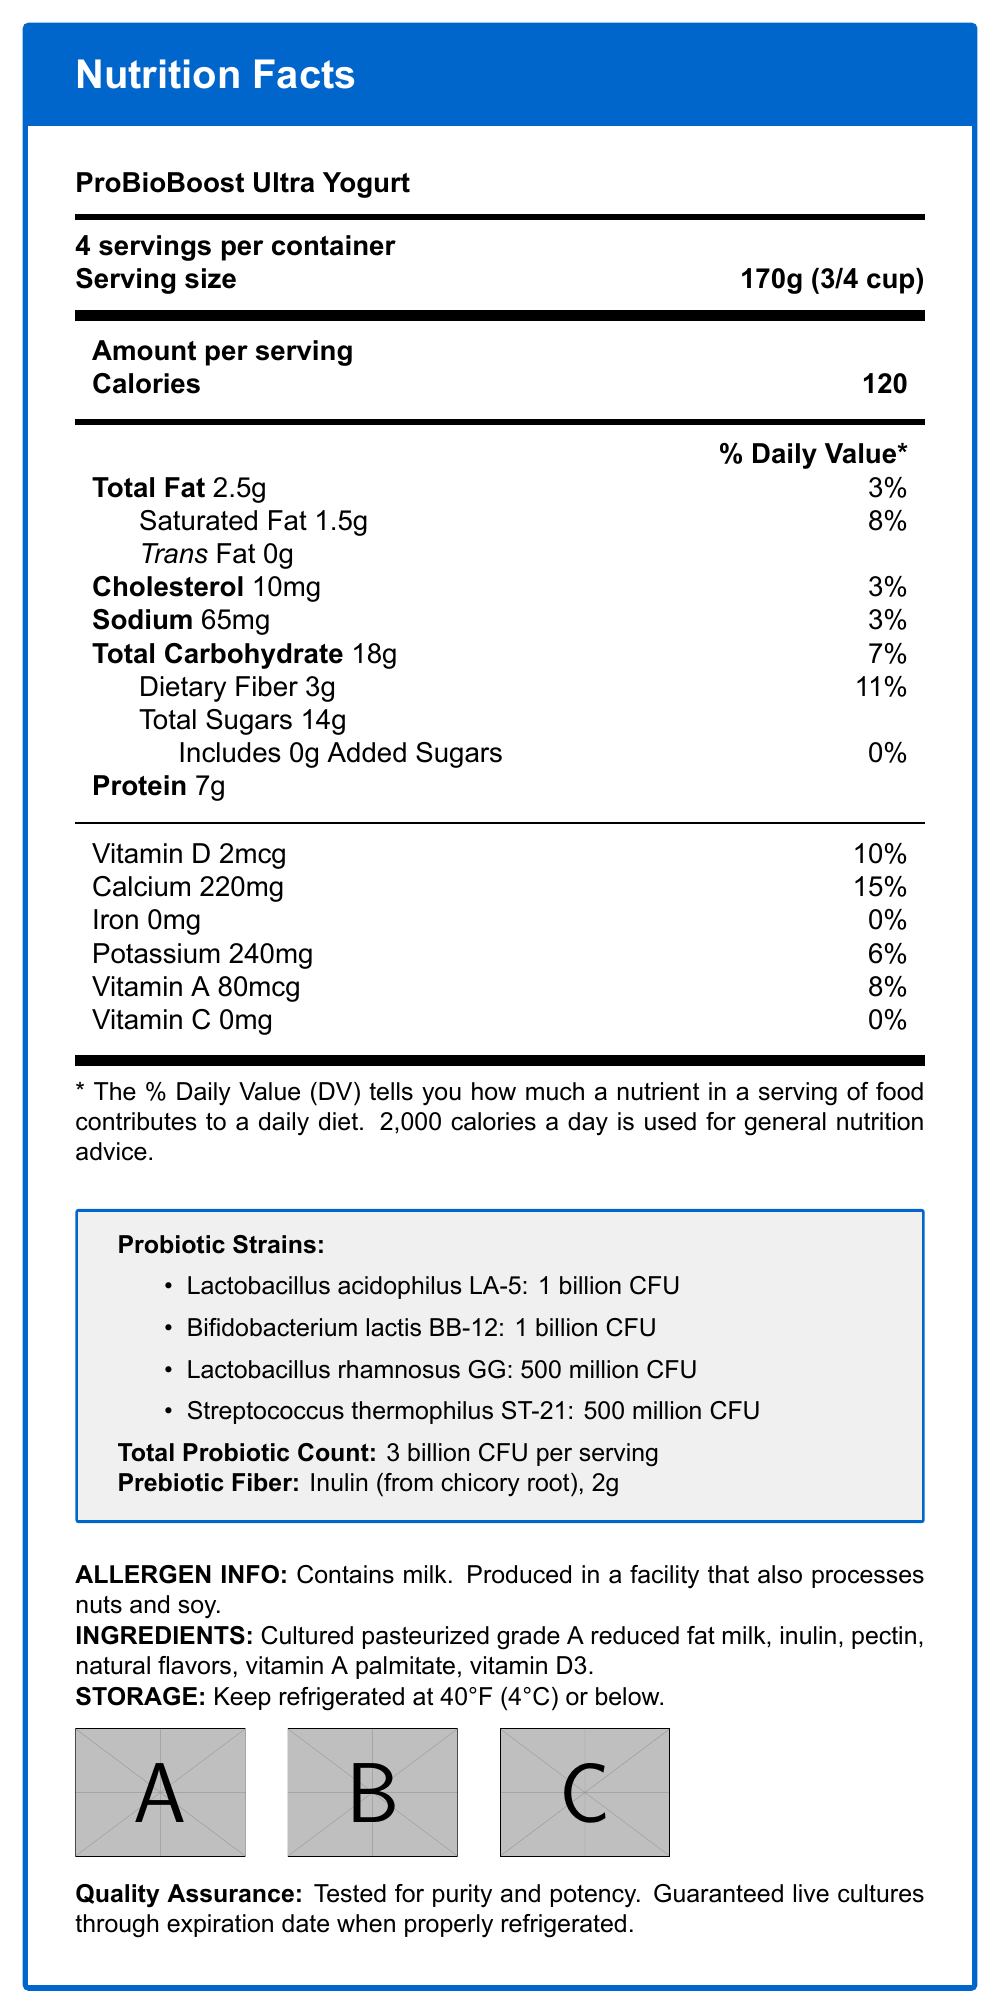what is the serving size of ProBioBoost Ultra Yogurt? The serving size is clearly listed at the top of the document as 170g (3/4 cup).
Answer: 170g (3/4 cup) how many calories are there per serving? The document states that there are 120 calories per serving.
Answer: 120 how much Vitamin D is in one serving and what percentage of the daily value does it represent? The document indicates that one serving contains 2mcg of Vitamin D, which is 10% of the daily value.
Answer: 2mcg, 10% what is the amount of dietary fiber per serving? The document lists the dietary fiber content as 3g per serving.
Answer: 3g name two probiotic strains listed on the document. The document mentions Lactobacillus acidophilus LA-5 and Bifidobacterium lactis BB-12 among the probiotic strains.
Answer: Lactobacillus acidophilus LA-5 and Bifidobacterium lactis BB-12 how many Total Sugars are there per serving in the ProBioBoost Ultra Yogurt? A. 10g B. 15g C. 14g D. 20g The document states that the Total Sugars content per serving is 14g.
Answer: C. 14g which of the following nutrients is not present in the yogurt? I. Iron II. Vitamin D III. Calcium IV. Potassium Iron is listed as 0mg per serving, making it not present in the yogurt.
Answer: I. Iron does this product contain any added sugars? The document indicates that it includes 0g of Added Sugars.
Answer: No is ProBioBoost Ultra Yogurt free from gluten and GMO ingredients? The Nutrition Facts Label shows certification labels indicating that the product is Gluten-Free and Non-GMO Project Verified.
Answer: Yes summarize the main components provided in the document. The document is comprehensive, detailing the nutritional values, probiotic content, ingredients, storage needs, and certifications, giving a clear overview of the product.
Answer: The document provides Nutrition Facts for ProBioBoost Ultra Yogurt, including serving size, calories, and nutrient content per serving. It also lists probiotic strains and counts, identifies prebiotic fiber content, allergen information, ingredients, storage instructions, quality assurance, and certification labels. what is the expiration date of the product? The document does not provide specific expiration date details, only the format for the expiration date.
Answer: Cannot be determined 